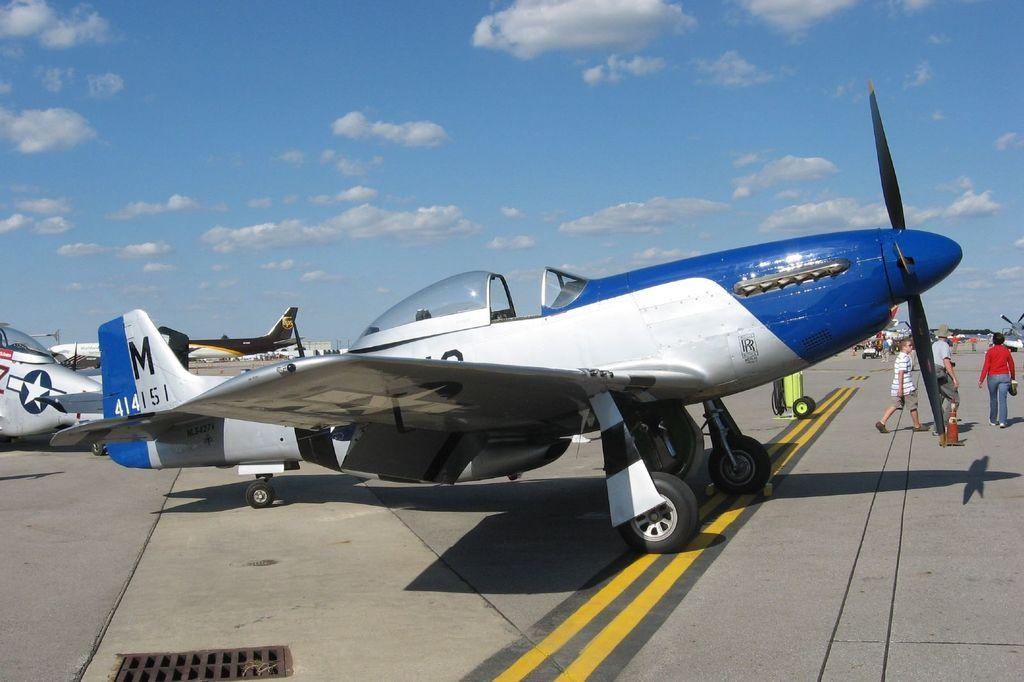<image>
Create a compact narrative representing the image presented. An airplane with the aircraft registration number of M414151. 